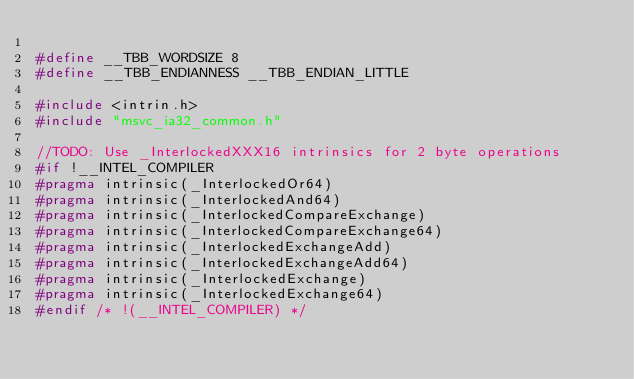Convert code to text. <code><loc_0><loc_0><loc_500><loc_500><_C_>
#define __TBB_WORDSIZE 8
#define __TBB_ENDIANNESS __TBB_ENDIAN_LITTLE

#include <intrin.h>
#include "msvc_ia32_common.h"

//TODO: Use _InterlockedXXX16 intrinsics for 2 byte operations
#if !__INTEL_COMPILER
#pragma intrinsic(_InterlockedOr64)
#pragma intrinsic(_InterlockedAnd64)
#pragma intrinsic(_InterlockedCompareExchange)
#pragma intrinsic(_InterlockedCompareExchange64)
#pragma intrinsic(_InterlockedExchangeAdd)
#pragma intrinsic(_InterlockedExchangeAdd64)
#pragma intrinsic(_InterlockedExchange)
#pragma intrinsic(_InterlockedExchange64)
#endif /* !(__INTEL_COMPILER) */
</code> 